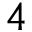Convert formula to latex. <formula><loc_0><loc_0><loc_500><loc_500>4</formula> 